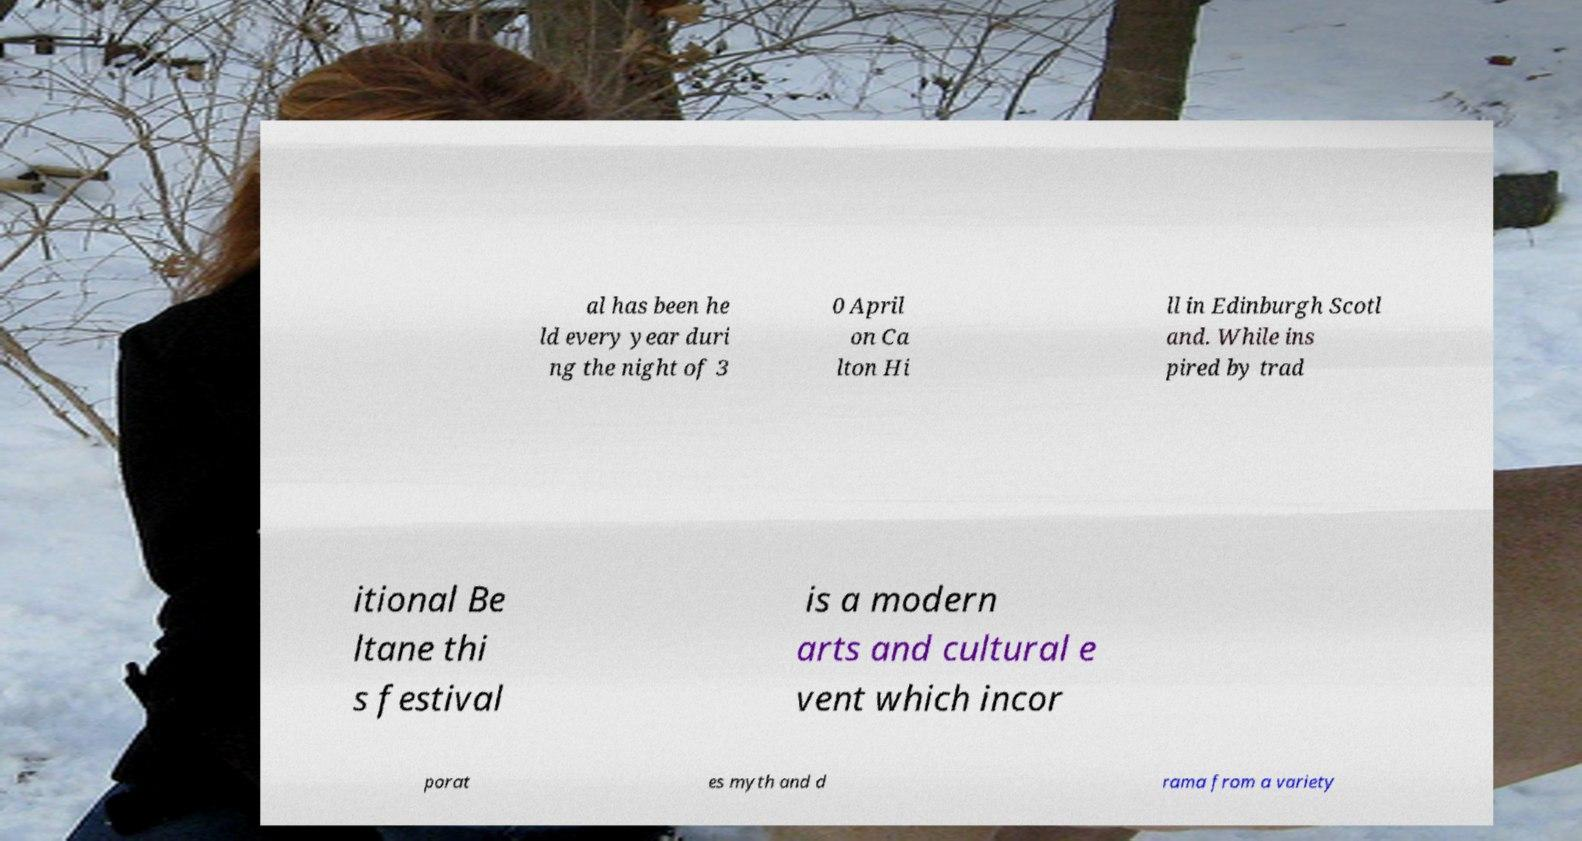For documentation purposes, I need the text within this image transcribed. Could you provide that? al has been he ld every year duri ng the night of 3 0 April on Ca lton Hi ll in Edinburgh Scotl and. While ins pired by trad itional Be ltane thi s festival is a modern arts and cultural e vent which incor porat es myth and d rama from a variety 